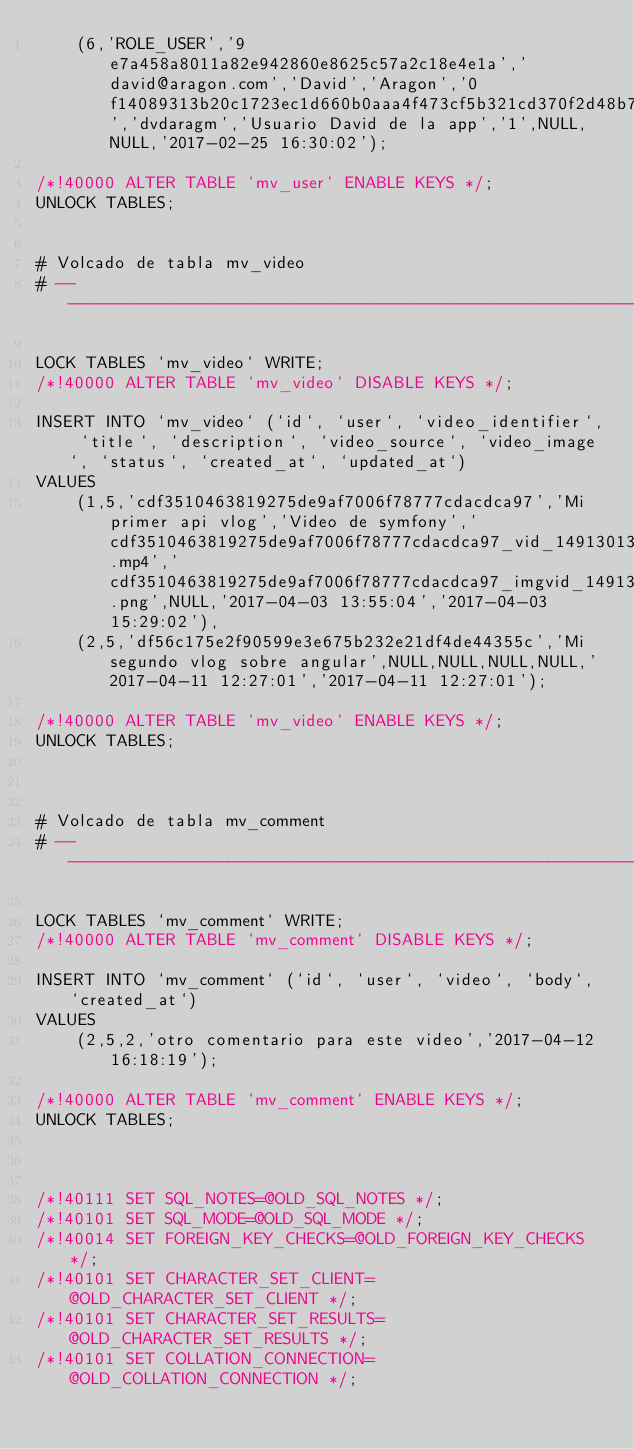Convert code to text. <code><loc_0><loc_0><loc_500><loc_500><_SQL_>	(6,'ROLE_USER','9e7a458a8011a82e942860e8625c57a2c18e4e1a','david@aragon.com','David','Aragon','0f14089313b20c1723ec1d660b0aaa4f473cf5b321cd370f2d48b7bcf9a7b234','dvdaragm','Usuario David de la app','1',NULL,NULL,'2017-02-25 16:30:02');

/*!40000 ALTER TABLE `mv_user` ENABLE KEYS */;
UNLOCK TABLES;


# Volcado de tabla mv_video
# ------------------------------------------------------------

LOCK TABLES `mv_video` WRITE;
/*!40000 ALTER TABLE `mv_video` DISABLE KEYS */;

INSERT INTO `mv_video` (`id`, `user`, `video_identifier`, `title`, `description`, `video_source`, `video_image`, `status`, `created_at`, `updated_at`)
VALUES
	(1,5,'cdf3510463819275de9af7006f78777cdacdca97','Mi primer api vlog','Video de symfony','cdf3510463819275de9af7006f78777cdacdca97_vid_1491301392.mp4','cdf3510463819275de9af7006f78777cdacdca97_imgvid_1491301447.png',NULL,'2017-04-03 13:55:04','2017-04-03 15:29:02'),
	(2,5,'df56c175e2f90599e3e675b232e21df4de44355c','Mi segundo vlog sobre angular',NULL,NULL,NULL,NULL,'2017-04-11 12:27:01','2017-04-11 12:27:01');

/*!40000 ALTER TABLE `mv_video` ENABLE KEYS */;
UNLOCK TABLES;



# Volcado de tabla mv_comment
# ------------------------------------------------------------

LOCK TABLES `mv_comment` WRITE;
/*!40000 ALTER TABLE `mv_comment` DISABLE KEYS */;

INSERT INTO `mv_comment` (`id`, `user`, `video`, `body`, `created_at`)
VALUES
	(2,5,2,'otro comentario para este video','2017-04-12 16:18:19');

/*!40000 ALTER TABLE `mv_comment` ENABLE KEYS */;
UNLOCK TABLES;



/*!40111 SET SQL_NOTES=@OLD_SQL_NOTES */;
/*!40101 SET SQL_MODE=@OLD_SQL_MODE */;
/*!40014 SET FOREIGN_KEY_CHECKS=@OLD_FOREIGN_KEY_CHECKS */;
/*!40101 SET CHARACTER_SET_CLIENT=@OLD_CHARACTER_SET_CLIENT */;
/*!40101 SET CHARACTER_SET_RESULTS=@OLD_CHARACTER_SET_RESULTS */;
/*!40101 SET COLLATION_CONNECTION=@OLD_COLLATION_CONNECTION */;
</code> 